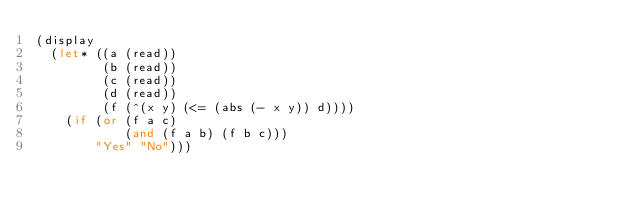Convert code to text. <code><loc_0><loc_0><loc_500><loc_500><_Scheme_>(display
  (let* ((a (read))
         (b (read))
         (c (read))
         (d (read))
         (f (^(x y) (<= (abs (- x y)) d))))
    (if (or (f a c)
            (and (f a b) (f b c)))
        "Yes" "No")))
</code> 